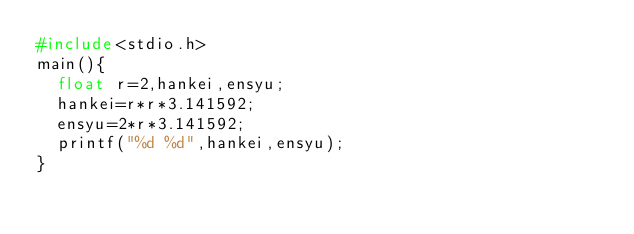Convert code to text. <code><loc_0><loc_0><loc_500><loc_500><_C_>#include<stdio.h>
main(){
  float r=2,hankei,ensyu;
  hankei=r*r*3.141592;
  ensyu=2*r*3.141592;
  printf("%d %d",hankei,ensyu);
}</code> 